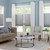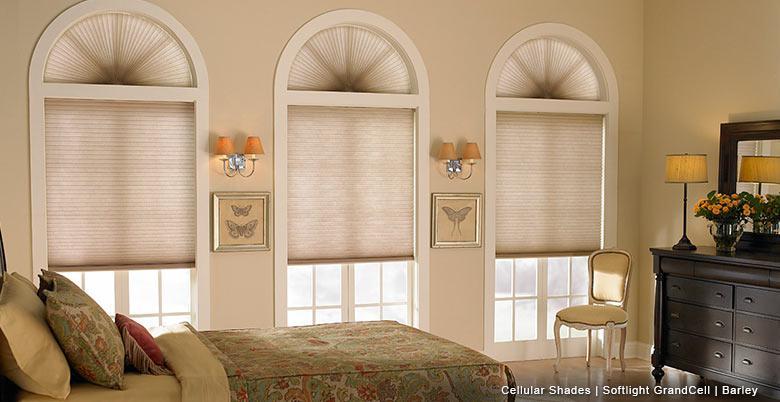The first image is the image on the left, the second image is the image on the right. Given the left and right images, does the statement "There is a total of two blinds." hold true? Answer yes or no. No. The first image is the image on the left, the second image is the image on the right. Analyze the images presented: Is the assertion "There is exactly one window in the right image." valid? Answer yes or no. No. 